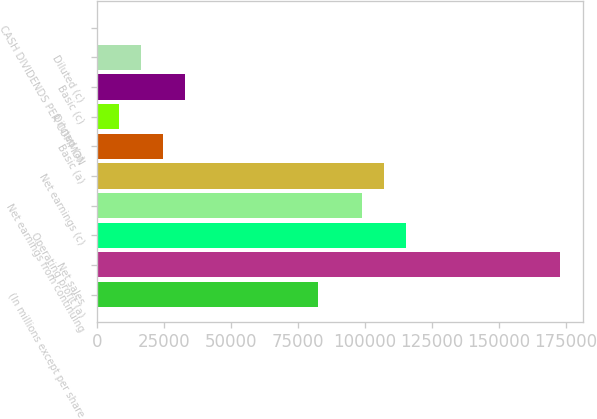Convert chart. <chart><loc_0><loc_0><loc_500><loc_500><bar_chart><fcel>(In millions except per share<fcel>Net sales<fcel>Operating profit (a)<fcel>Net earnings from continuing<fcel>Net earnings (c)<fcel>Basic (a)<fcel>Diluted (a)<fcel>Basic (c)<fcel>Diluted (c)<fcel>CASH DIVIDENDS PER COMMON<nl><fcel>82300<fcel>172825<fcel>115218<fcel>98759.2<fcel>106989<fcel>24692.9<fcel>8233.74<fcel>32922.5<fcel>16463.3<fcel>4.15<nl></chart> 